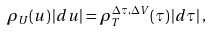<formula> <loc_0><loc_0><loc_500><loc_500>\rho _ { U } ( u ) \left | d u \right | = \rho _ { T } ^ { \Delta \tau , \Delta V } ( \tau ) \left | d \tau \right | ,</formula> 